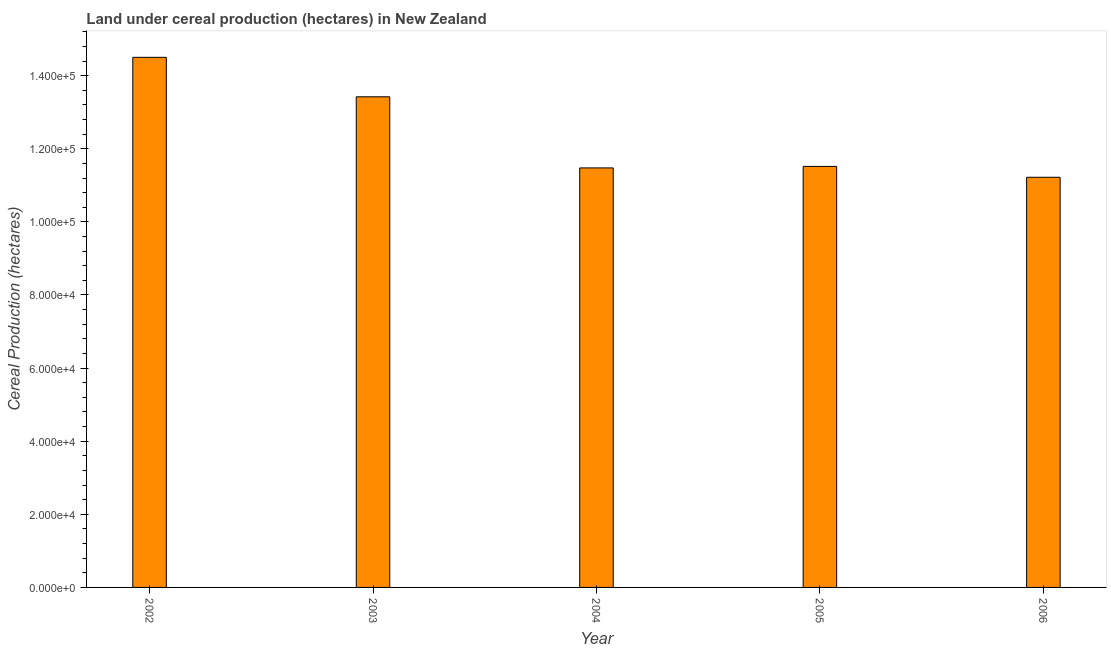Does the graph contain grids?
Your answer should be compact. No. What is the title of the graph?
Offer a terse response. Land under cereal production (hectares) in New Zealand. What is the label or title of the X-axis?
Your response must be concise. Year. What is the label or title of the Y-axis?
Give a very brief answer. Cereal Production (hectares). What is the land under cereal production in 2006?
Make the answer very short. 1.12e+05. Across all years, what is the maximum land under cereal production?
Provide a succinct answer. 1.45e+05. Across all years, what is the minimum land under cereal production?
Give a very brief answer. 1.12e+05. What is the sum of the land under cereal production?
Offer a very short reply. 6.21e+05. What is the difference between the land under cereal production in 2003 and 2004?
Offer a terse response. 1.95e+04. What is the average land under cereal production per year?
Provide a short and direct response. 1.24e+05. What is the median land under cereal production?
Offer a very short reply. 1.15e+05. In how many years, is the land under cereal production greater than 44000 hectares?
Provide a succinct answer. 5. Do a majority of the years between 2002 and 2006 (inclusive) have land under cereal production greater than 148000 hectares?
Keep it short and to the point. No. What is the ratio of the land under cereal production in 2002 to that in 2006?
Offer a terse response. 1.29. Is the land under cereal production in 2002 less than that in 2003?
Offer a very short reply. No. Is the difference between the land under cereal production in 2005 and 2006 greater than the difference between any two years?
Provide a short and direct response. No. What is the difference between the highest and the second highest land under cereal production?
Make the answer very short. 1.08e+04. What is the difference between the highest and the lowest land under cereal production?
Provide a short and direct response. 3.28e+04. In how many years, is the land under cereal production greater than the average land under cereal production taken over all years?
Your response must be concise. 2. What is the difference between two consecutive major ticks on the Y-axis?
Your response must be concise. 2.00e+04. Are the values on the major ticks of Y-axis written in scientific E-notation?
Your response must be concise. Yes. What is the Cereal Production (hectares) of 2002?
Your response must be concise. 1.45e+05. What is the Cereal Production (hectares) in 2003?
Offer a terse response. 1.34e+05. What is the Cereal Production (hectares) of 2004?
Your response must be concise. 1.15e+05. What is the Cereal Production (hectares) of 2005?
Give a very brief answer. 1.15e+05. What is the Cereal Production (hectares) of 2006?
Your answer should be very brief. 1.12e+05. What is the difference between the Cereal Production (hectares) in 2002 and 2003?
Your response must be concise. 1.08e+04. What is the difference between the Cereal Production (hectares) in 2002 and 2004?
Make the answer very short. 3.03e+04. What is the difference between the Cereal Production (hectares) in 2002 and 2005?
Offer a very short reply. 2.98e+04. What is the difference between the Cereal Production (hectares) in 2002 and 2006?
Offer a very short reply. 3.28e+04. What is the difference between the Cereal Production (hectares) in 2003 and 2004?
Provide a short and direct response. 1.95e+04. What is the difference between the Cereal Production (hectares) in 2003 and 2005?
Provide a short and direct response. 1.90e+04. What is the difference between the Cereal Production (hectares) in 2003 and 2006?
Your response must be concise. 2.20e+04. What is the difference between the Cereal Production (hectares) in 2004 and 2005?
Offer a terse response. -413. What is the difference between the Cereal Production (hectares) in 2004 and 2006?
Ensure brevity in your answer.  2558. What is the difference between the Cereal Production (hectares) in 2005 and 2006?
Give a very brief answer. 2971. What is the ratio of the Cereal Production (hectares) in 2002 to that in 2004?
Your answer should be very brief. 1.26. What is the ratio of the Cereal Production (hectares) in 2002 to that in 2005?
Provide a succinct answer. 1.26. What is the ratio of the Cereal Production (hectares) in 2002 to that in 2006?
Provide a succinct answer. 1.29. What is the ratio of the Cereal Production (hectares) in 2003 to that in 2004?
Keep it short and to the point. 1.17. What is the ratio of the Cereal Production (hectares) in 2003 to that in 2005?
Offer a very short reply. 1.17. What is the ratio of the Cereal Production (hectares) in 2003 to that in 2006?
Your answer should be compact. 1.2. What is the ratio of the Cereal Production (hectares) in 2004 to that in 2005?
Offer a very short reply. 1. 